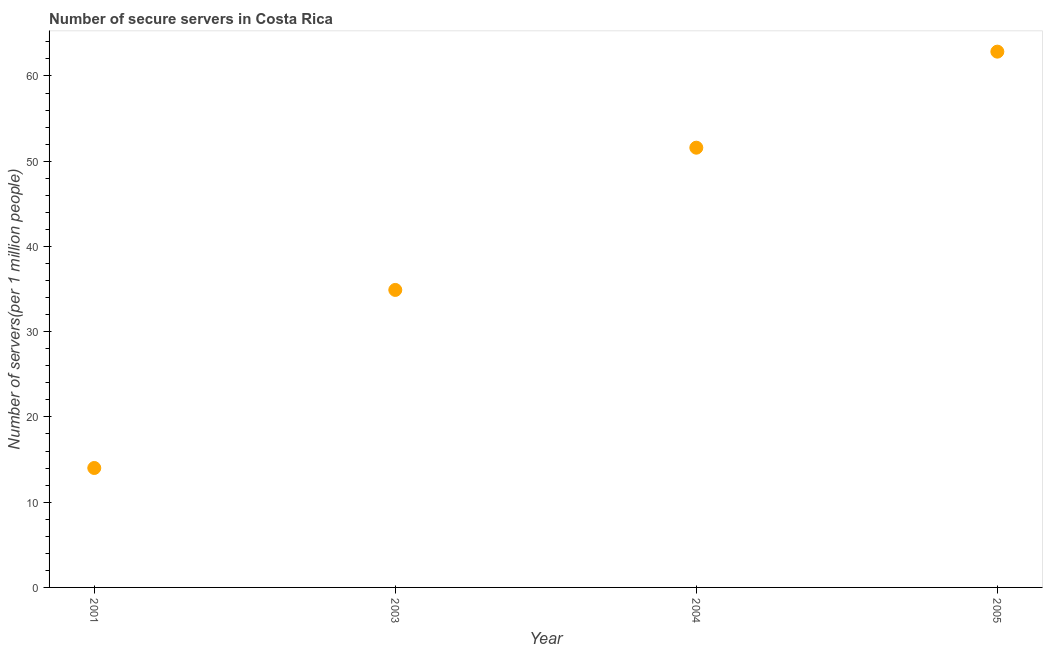What is the number of secure internet servers in 2003?
Your answer should be compact. 34.9. Across all years, what is the maximum number of secure internet servers?
Keep it short and to the point. 62.86. Across all years, what is the minimum number of secure internet servers?
Your response must be concise. 14.01. In which year was the number of secure internet servers maximum?
Offer a terse response. 2005. What is the sum of the number of secure internet servers?
Provide a short and direct response. 163.36. What is the difference between the number of secure internet servers in 2004 and 2005?
Offer a very short reply. -11.27. What is the average number of secure internet servers per year?
Offer a very short reply. 40.84. What is the median number of secure internet servers?
Make the answer very short. 43.24. Do a majority of the years between 2001 and 2004 (inclusive) have number of secure internet servers greater than 10 ?
Your response must be concise. Yes. What is the ratio of the number of secure internet servers in 2003 to that in 2004?
Provide a short and direct response. 0.68. Is the difference between the number of secure internet servers in 2001 and 2003 greater than the difference between any two years?
Provide a short and direct response. No. What is the difference between the highest and the second highest number of secure internet servers?
Your response must be concise. 11.27. What is the difference between the highest and the lowest number of secure internet servers?
Provide a short and direct response. 48.84. In how many years, is the number of secure internet servers greater than the average number of secure internet servers taken over all years?
Give a very brief answer. 2. Does the number of secure internet servers monotonically increase over the years?
Provide a succinct answer. Yes. How many dotlines are there?
Your answer should be very brief. 1. What is the difference between two consecutive major ticks on the Y-axis?
Your answer should be compact. 10. Are the values on the major ticks of Y-axis written in scientific E-notation?
Keep it short and to the point. No. Does the graph contain any zero values?
Your answer should be compact. No. What is the title of the graph?
Your answer should be very brief. Number of secure servers in Costa Rica. What is the label or title of the X-axis?
Ensure brevity in your answer.  Year. What is the label or title of the Y-axis?
Make the answer very short. Number of servers(per 1 million people). What is the Number of servers(per 1 million people) in 2001?
Your answer should be very brief. 14.01. What is the Number of servers(per 1 million people) in 2003?
Your answer should be compact. 34.9. What is the Number of servers(per 1 million people) in 2004?
Your response must be concise. 51.59. What is the Number of servers(per 1 million people) in 2005?
Offer a terse response. 62.86. What is the difference between the Number of servers(per 1 million people) in 2001 and 2003?
Ensure brevity in your answer.  -20.89. What is the difference between the Number of servers(per 1 million people) in 2001 and 2004?
Offer a terse response. -37.58. What is the difference between the Number of servers(per 1 million people) in 2001 and 2005?
Offer a terse response. -48.84. What is the difference between the Number of servers(per 1 million people) in 2003 and 2004?
Your response must be concise. -16.69. What is the difference between the Number of servers(per 1 million people) in 2003 and 2005?
Your response must be concise. -27.95. What is the difference between the Number of servers(per 1 million people) in 2004 and 2005?
Provide a short and direct response. -11.27. What is the ratio of the Number of servers(per 1 million people) in 2001 to that in 2003?
Offer a terse response. 0.4. What is the ratio of the Number of servers(per 1 million people) in 2001 to that in 2004?
Make the answer very short. 0.27. What is the ratio of the Number of servers(per 1 million people) in 2001 to that in 2005?
Your response must be concise. 0.22. What is the ratio of the Number of servers(per 1 million people) in 2003 to that in 2004?
Offer a terse response. 0.68. What is the ratio of the Number of servers(per 1 million people) in 2003 to that in 2005?
Give a very brief answer. 0.56. What is the ratio of the Number of servers(per 1 million people) in 2004 to that in 2005?
Provide a short and direct response. 0.82. 